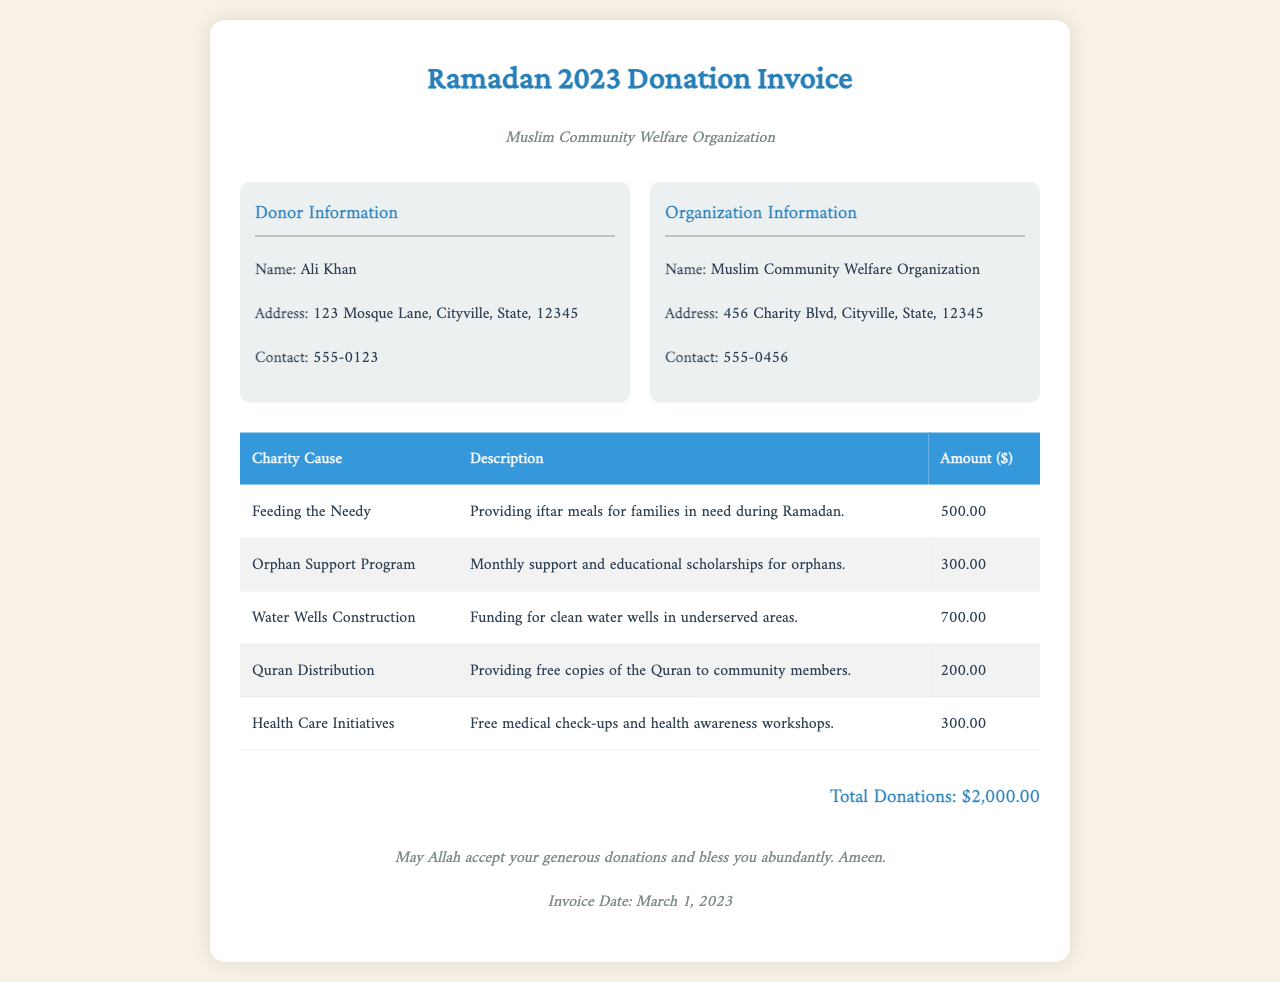What is the total amount of donations? The total amount of donations is displayed at the bottom of the invoice, which sums up all individual charity causes.
Answer: $2,000.00 Who is the donor? The donor's information includes the name listed at the top of the invoice.
Answer: Ali Khan What is the purpose of the "Water Wells Construction" donation? The description provides clarity on the purpose of this specific donation, which is aimed at serving underserved communities.
Answer: Funding for clean water wells in underserved areas How much was donated for the "Orphan Support Program"? This information is found in the table detailing the amounts allocated to different charity causes.
Answer: $300.00 When was the invoice date? The invoice date is provided at the bottom of the document and indicates when the invoice was issued.
Answer: March 1, 2023 What organization is receiving the donations? The organization's name is mentioned in the header section of the invoice, identifying the entity managing this charitable effort.
Answer: Muslim Community Welfare Organization How much was allocated for "Feeding the Needy"? The allocation for this charity cause is specifically noted in the amount column of the table.
Answer: $500.00 What type of initiative is covered under "Health Care Initiatives"? The initiatives are described in the document which outlines the activities funded by this donation.
Answer: Free medical check-ups and health awareness workshops What is the significance of the final statement in the footer? The footer contains a message that expresses a wish for blessings on the donor for their generosity, reinforcing community values.
Answer: May Allah accept your generous donations and bless you abundantly. Ameen 